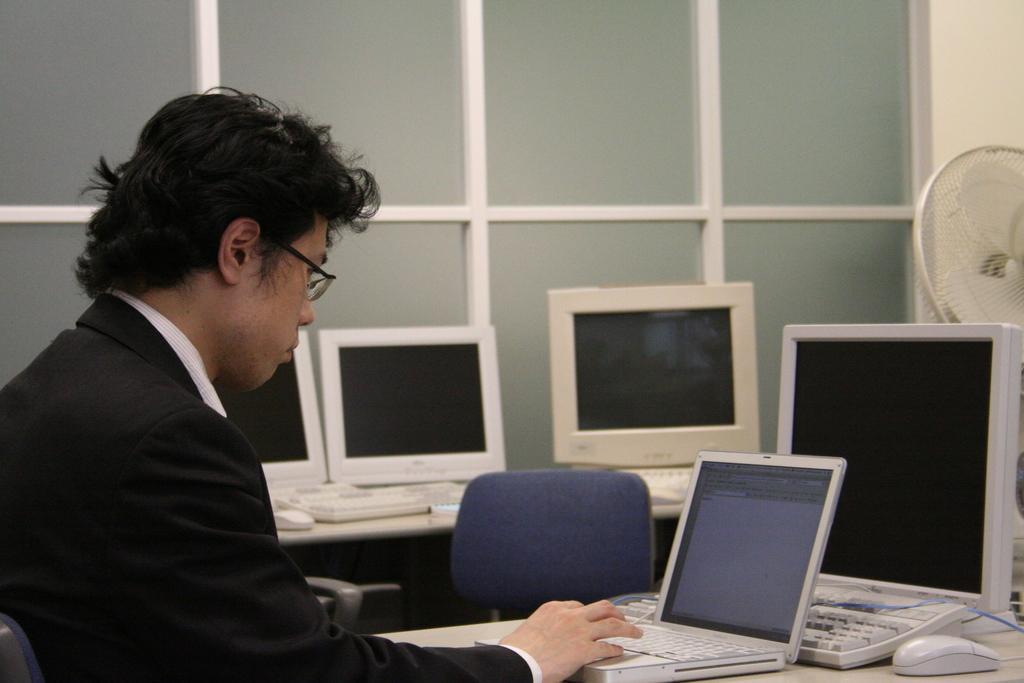Can you describe this image briefly? In the picture there is a person sitting in front of the table and working with the laptop, there are many computers around him and on the right side there is a table fan behind the computer and in the background there are many windows beside the wall. 